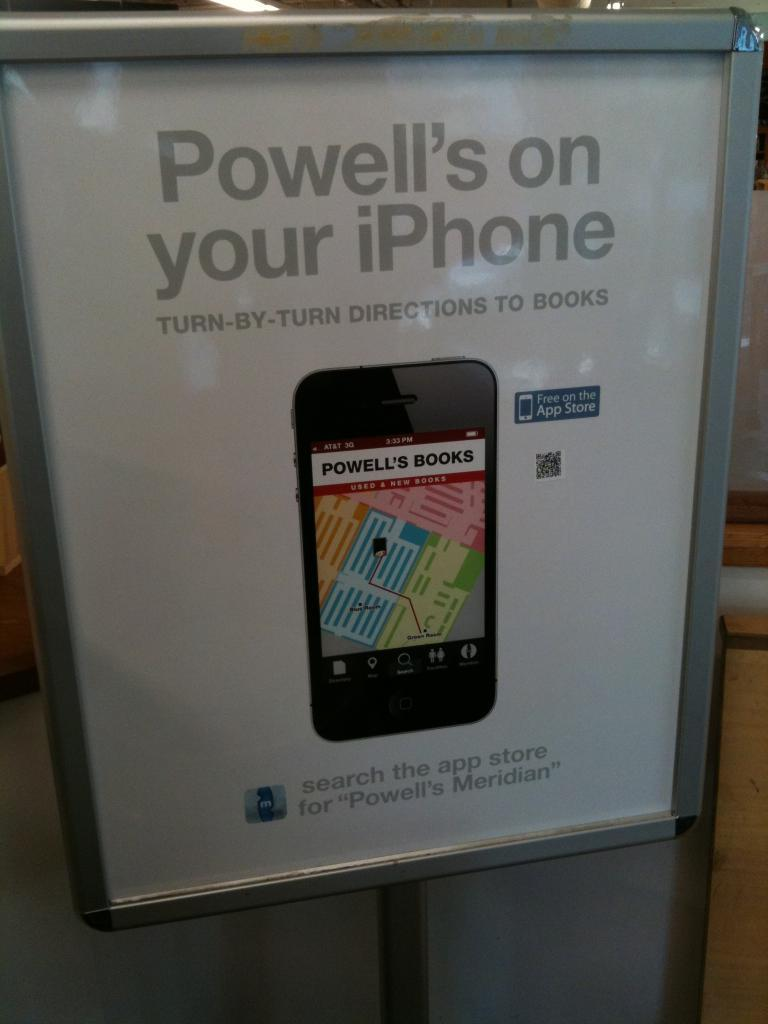Provide a one-sentence caption for the provided image. An advertisement for turn by turn directions to books. 